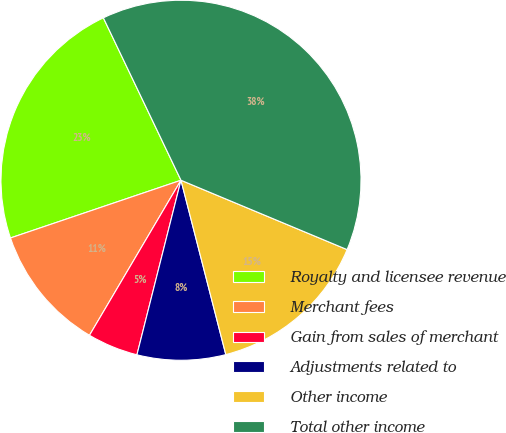Convert chart. <chart><loc_0><loc_0><loc_500><loc_500><pie_chart><fcel>Royalty and licensee revenue<fcel>Merchant fees<fcel>Gain from sales of merchant<fcel>Adjustments related to<fcel>Other income<fcel>Total other income<nl><fcel>23.1%<fcel>11.32%<fcel>4.55%<fcel>7.94%<fcel>14.7%<fcel>38.39%<nl></chart> 